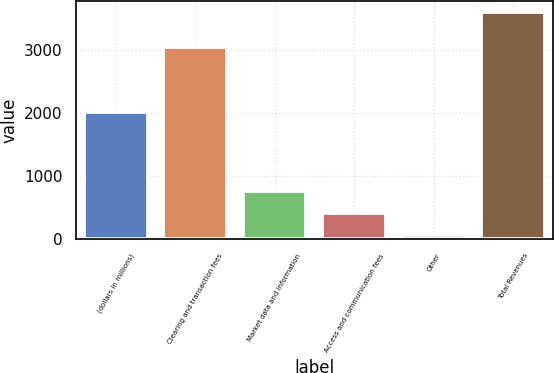<chart> <loc_0><loc_0><loc_500><loc_500><bar_chart><fcel>(dollars in millions)<fcel>Clearing and transaction fees<fcel>Market data and information<fcel>Access and communication fees<fcel>Other<fcel>Total Revenues<nl><fcel>2016<fcel>3036.4<fcel>767.76<fcel>414.33<fcel>60.9<fcel>3595.2<nl></chart> 